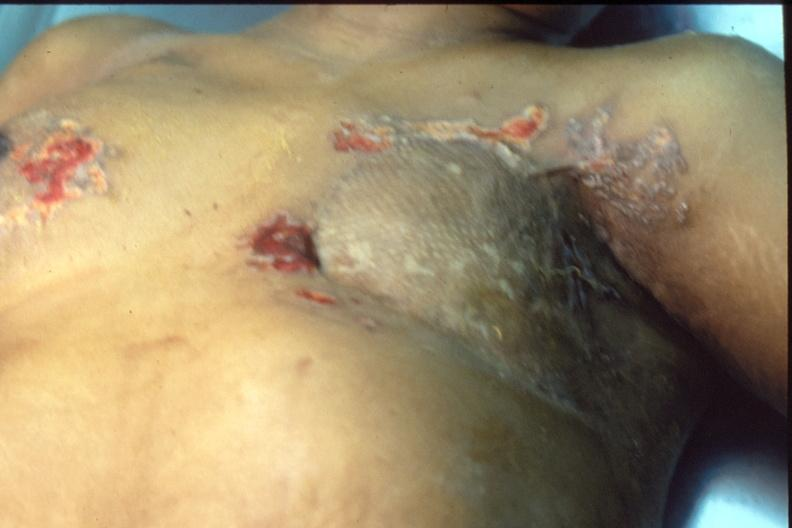what is present?
Answer the question using a single word or phrase. Breast 